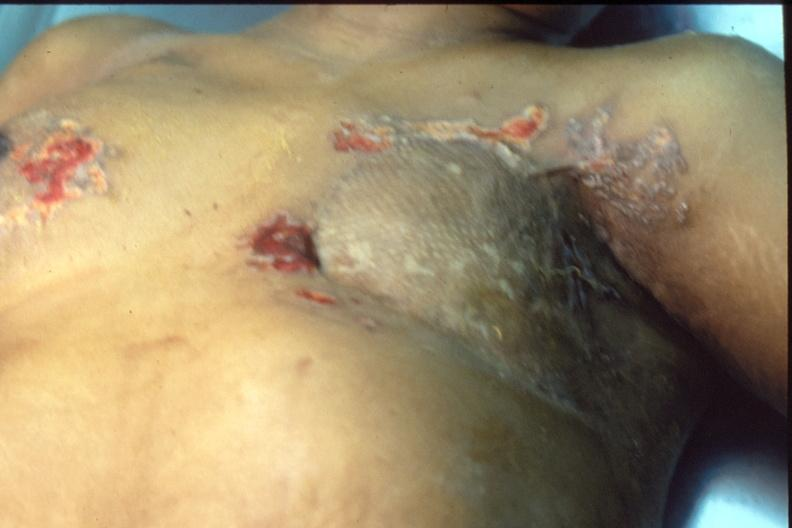what is present?
Answer the question using a single word or phrase. Breast 